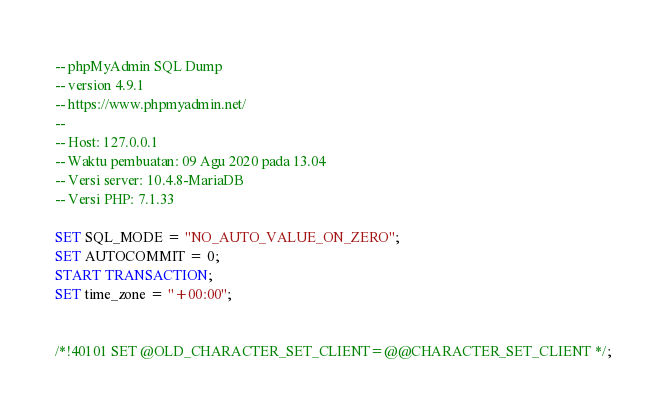Convert code to text. <code><loc_0><loc_0><loc_500><loc_500><_SQL_>-- phpMyAdmin SQL Dump
-- version 4.9.1
-- https://www.phpmyadmin.net/
--
-- Host: 127.0.0.1
-- Waktu pembuatan: 09 Agu 2020 pada 13.04
-- Versi server: 10.4.8-MariaDB
-- Versi PHP: 7.1.33

SET SQL_MODE = "NO_AUTO_VALUE_ON_ZERO";
SET AUTOCOMMIT = 0;
START TRANSACTION;
SET time_zone = "+00:00";


/*!40101 SET @OLD_CHARACTER_SET_CLIENT=@@CHARACTER_SET_CLIENT */;</code> 